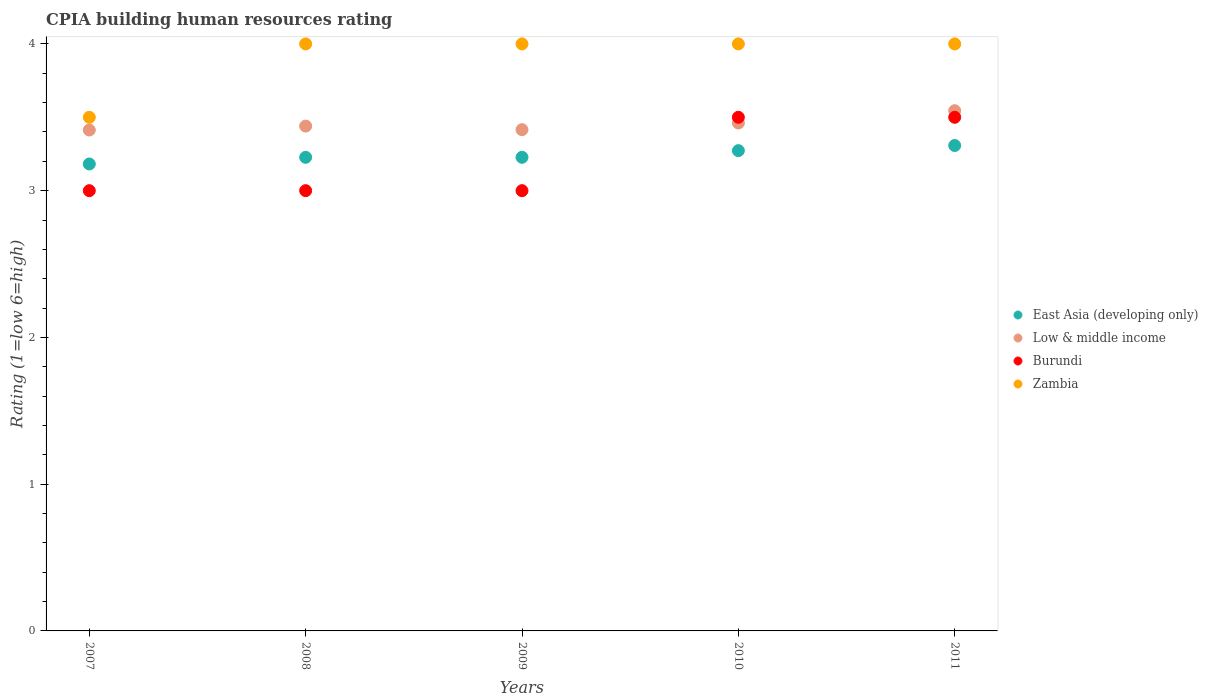Is the number of dotlines equal to the number of legend labels?
Provide a short and direct response. Yes. Across all years, what is the minimum CPIA rating in Zambia?
Keep it short and to the point. 3.5. In which year was the CPIA rating in Low & middle income minimum?
Your response must be concise. 2007. What is the difference between the CPIA rating in Low & middle income in 2009 and that in 2011?
Your answer should be compact. -0.13. What is the difference between the CPIA rating in Zambia in 2009 and the CPIA rating in East Asia (developing only) in 2007?
Make the answer very short. 0.82. What is the average CPIA rating in Low & middle income per year?
Provide a short and direct response. 3.45. In the year 2009, what is the difference between the CPIA rating in Low & middle income and CPIA rating in Zambia?
Your answer should be very brief. -0.58. What is the ratio of the CPIA rating in East Asia (developing only) in 2007 to that in 2009?
Offer a terse response. 0.99. What is the difference between the highest and the lowest CPIA rating in East Asia (developing only)?
Ensure brevity in your answer.  0.13. In how many years, is the CPIA rating in Zambia greater than the average CPIA rating in Zambia taken over all years?
Your response must be concise. 4. Is the sum of the CPIA rating in Burundi in 2007 and 2011 greater than the maximum CPIA rating in Low & middle income across all years?
Offer a very short reply. Yes. Is it the case that in every year, the sum of the CPIA rating in Burundi and CPIA rating in Low & middle income  is greater than the sum of CPIA rating in East Asia (developing only) and CPIA rating in Zambia?
Your response must be concise. No. Is it the case that in every year, the sum of the CPIA rating in East Asia (developing only) and CPIA rating in Burundi  is greater than the CPIA rating in Zambia?
Your answer should be compact. Yes. Is the CPIA rating in East Asia (developing only) strictly greater than the CPIA rating in Zambia over the years?
Your response must be concise. No. Does the graph contain grids?
Give a very brief answer. No. How many legend labels are there?
Offer a very short reply. 4. How are the legend labels stacked?
Provide a short and direct response. Vertical. What is the title of the graph?
Your answer should be very brief. CPIA building human resources rating. Does "Caribbean small states" appear as one of the legend labels in the graph?
Offer a very short reply. No. What is the Rating (1=low 6=high) in East Asia (developing only) in 2007?
Make the answer very short. 3.18. What is the Rating (1=low 6=high) of Low & middle income in 2007?
Your response must be concise. 3.41. What is the Rating (1=low 6=high) in Zambia in 2007?
Ensure brevity in your answer.  3.5. What is the Rating (1=low 6=high) of East Asia (developing only) in 2008?
Provide a short and direct response. 3.23. What is the Rating (1=low 6=high) of Low & middle income in 2008?
Provide a short and direct response. 3.44. What is the Rating (1=low 6=high) of Burundi in 2008?
Provide a short and direct response. 3. What is the Rating (1=low 6=high) in East Asia (developing only) in 2009?
Give a very brief answer. 3.23. What is the Rating (1=low 6=high) in Low & middle income in 2009?
Give a very brief answer. 3.42. What is the Rating (1=low 6=high) in Burundi in 2009?
Keep it short and to the point. 3. What is the Rating (1=low 6=high) in East Asia (developing only) in 2010?
Offer a very short reply. 3.27. What is the Rating (1=low 6=high) in Low & middle income in 2010?
Your answer should be compact. 3.46. What is the Rating (1=low 6=high) of Burundi in 2010?
Offer a terse response. 3.5. What is the Rating (1=low 6=high) in Zambia in 2010?
Offer a terse response. 4. What is the Rating (1=low 6=high) in East Asia (developing only) in 2011?
Make the answer very short. 3.31. What is the Rating (1=low 6=high) in Low & middle income in 2011?
Your answer should be compact. 3.54. Across all years, what is the maximum Rating (1=low 6=high) of East Asia (developing only)?
Ensure brevity in your answer.  3.31. Across all years, what is the maximum Rating (1=low 6=high) in Low & middle income?
Your answer should be compact. 3.54. Across all years, what is the maximum Rating (1=low 6=high) in Zambia?
Keep it short and to the point. 4. Across all years, what is the minimum Rating (1=low 6=high) of East Asia (developing only)?
Your response must be concise. 3.18. Across all years, what is the minimum Rating (1=low 6=high) of Low & middle income?
Offer a very short reply. 3.41. Across all years, what is the minimum Rating (1=low 6=high) of Burundi?
Provide a succinct answer. 3. Across all years, what is the minimum Rating (1=low 6=high) in Zambia?
Offer a very short reply. 3.5. What is the total Rating (1=low 6=high) in East Asia (developing only) in the graph?
Ensure brevity in your answer.  16.22. What is the total Rating (1=low 6=high) of Low & middle income in the graph?
Keep it short and to the point. 17.27. What is the total Rating (1=low 6=high) of Zambia in the graph?
Your answer should be very brief. 19.5. What is the difference between the Rating (1=low 6=high) of East Asia (developing only) in 2007 and that in 2008?
Keep it short and to the point. -0.05. What is the difference between the Rating (1=low 6=high) in Low & middle income in 2007 and that in 2008?
Your answer should be compact. -0.03. What is the difference between the Rating (1=low 6=high) in East Asia (developing only) in 2007 and that in 2009?
Your answer should be compact. -0.05. What is the difference between the Rating (1=low 6=high) of Low & middle income in 2007 and that in 2009?
Your answer should be compact. -0. What is the difference between the Rating (1=low 6=high) in East Asia (developing only) in 2007 and that in 2010?
Keep it short and to the point. -0.09. What is the difference between the Rating (1=low 6=high) in Low & middle income in 2007 and that in 2010?
Your answer should be compact. -0.05. What is the difference between the Rating (1=low 6=high) in Zambia in 2007 and that in 2010?
Your answer should be compact. -0.5. What is the difference between the Rating (1=low 6=high) in East Asia (developing only) in 2007 and that in 2011?
Your answer should be very brief. -0.13. What is the difference between the Rating (1=low 6=high) in Low & middle income in 2007 and that in 2011?
Offer a terse response. -0.13. What is the difference between the Rating (1=low 6=high) of Burundi in 2007 and that in 2011?
Offer a terse response. -0.5. What is the difference between the Rating (1=low 6=high) of East Asia (developing only) in 2008 and that in 2009?
Your answer should be very brief. 0. What is the difference between the Rating (1=low 6=high) in Low & middle income in 2008 and that in 2009?
Provide a succinct answer. 0.02. What is the difference between the Rating (1=low 6=high) in Zambia in 2008 and that in 2009?
Offer a terse response. 0. What is the difference between the Rating (1=low 6=high) of East Asia (developing only) in 2008 and that in 2010?
Provide a short and direct response. -0.05. What is the difference between the Rating (1=low 6=high) of Low & middle income in 2008 and that in 2010?
Make the answer very short. -0.02. What is the difference between the Rating (1=low 6=high) of Burundi in 2008 and that in 2010?
Your answer should be very brief. -0.5. What is the difference between the Rating (1=low 6=high) in Zambia in 2008 and that in 2010?
Your answer should be very brief. 0. What is the difference between the Rating (1=low 6=high) of East Asia (developing only) in 2008 and that in 2011?
Your answer should be very brief. -0.08. What is the difference between the Rating (1=low 6=high) of Low & middle income in 2008 and that in 2011?
Provide a short and direct response. -0.1. What is the difference between the Rating (1=low 6=high) in Burundi in 2008 and that in 2011?
Your response must be concise. -0.5. What is the difference between the Rating (1=low 6=high) of East Asia (developing only) in 2009 and that in 2010?
Your answer should be very brief. -0.05. What is the difference between the Rating (1=low 6=high) of Low & middle income in 2009 and that in 2010?
Provide a succinct answer. -0.05. What is the difference between the Rating (1=low 6=high) of Burundi in 2009 and that in 2010?
Offer a very short reply. -0.5. What is the difference between the Rating (1=low 6=high) of Zambia in 2009 and that in 2010?
Your answer should be very brief. 0. What is the difference between the Rating (1=low 6=high) of East Asia (developing only) in 2009 and that in 2011?
Your answer should be very brief. -0.08. What is the difference between the Rating (1=low 6=high) of Low & middle income in 2009 and that in 2011?
Offer a very short reply. -0.13. What is the difference between the Rating (1=low 6=high) in Burundi in 2009 and that in 2011?
Give a very brief answer. -0.5. What is the difference between the Rating (1=low 6=high) of Zambia in 2009 and that in 2011?
Make the answer very short. 0. What is the difference between the Rating (1=low 6=high) in East Asia (developing only) in 2010 and that in 2011?
Offer a very short reply. -0.04. What is the difference between the Rating (1=low 6=high) of Low & middle income in 2010 and that in 2011?
Provide a short and direct response. -0.08. What is the difference between the Rating (1=low 6=high) in Zambia in 2010 and that in 2011?
Ensure brevity in your answer.  0. What is the difference between the Rating (1=low 6=high) in East Asia (developing only) in 2007 and the Rating (1=low 6=high) in Low & middle income in 2008?
Give a very brief answer. -0.26. What is the difference between the Rating (1=low 6=high) in East Asia (developing only) in 2007 and the Rating (1=low 6=high) in Burundi in 2008?
Make the answer very short. 0.18. What is the difference between the Rating (1=low 6=high) of East Asia (developing only) in 2007 and the Rating (1=low 6=high) of Zambia in 2008?
Keep it short and to the point. -0.82. What is the difference between the Rating (1=low 6=high) in Low & middle income in 2007 and the Rating (1=low 6=high) in Burundi in 2008?
Your answer should be very brief. 0.41. What is the difference between the Rating (1=low 6=high) of Low & middle income in 2007 and the Rating (1=low 6=high) of Zambia in 2008?
Provide a short and direct response. -0.59. What is the difference between the Rating (1=low 6=high) of East Asia (developing only) in 2007 and the Rating (1=low 6=high) of Low & middle income in 2009?
Your response must be concise. -0.23. What is the difference between the Rating (1=low 6=high) in East Asia (developing only) in 2007 and the Rating (1=low 6=high) in Burundi in 2009?
Offer a terse response. 0.18. What is the difference between the Rating (1=low 6=high) in East Asia (developing only) in 2007 and the Rating (1=low 6=high) in Zambia in 2009?
Offer a terse response. -0.82. What is the difference between the Rating (1=low 6=high) in Low & middle income in 2007 and the Rating (1=low 6=high) in Burundi in 2009?
Your response must be concise. 0.41. What is the difference between the Rating (1=low 6=high) in Low & middle income in 2007 and the Rating (1=low 6=high) in Zambia in 2009?
Your answer should be very brief. -0.59. What is the difference between the Rating (1=low 6=high) of Burundi in 2007 and the Rating (1=low 6=high) of Zambia in 2009?
Give a very brief answer. -1. What is the difference between the Rating (1=low 6=high) of East Asia (developing only) in 2007 and the Rating (1=low 6=high) of Low & middle income in 2010?
Keep it short and to the point. -0.28. What is the difference between the Rating (1=low 6=high) of East Asia (developing only) in 2007 and the Rating (1=low 6=high) of Burundi in 2010?
Provide a succinct answer. -0.32. What is the difference between the Rating (1=low 6=high) in East Asia (developing only) in 2007 and the Rating (1=low 6=high) in Zambia in 2010?
Provide a succinct answer. -0.82. What is the difference between the Rating (1=low 6=high) of Low & middle income in 2007 and the Rating (1=low 6=high) of Burundi in 2010?
Keep it short and to the point. -0.09. What is the difference between the Rating (1=low 6=high) of Low & middle income in 2007 and the Rating (1=low 6=high) of Zambia in 2010?
Provide a short and direct response. -0.59. What is the difference between the Rating (1=low 6=high) of East Asia (developing only) in 2007 and the Rating (1=low 6=high) of Low & middle income in 2011?
Provide a short and direct response. -0.36. What is the difference between the Rating (1=low 6=high) in East Asia (developing only) in 2007 and the Rating (1=low 6=high) in Burundi in 2011?
Your response must be concise. -0.32. What is the difference between the Rating (1=low 6=high) in East Asia (developing only) in 2007 and the Rating (1=low 6=high) in Zambia in 2011?
Ensure brevity in your answer.  -0.82. What is the difference between the Rating (1=low 6=high) in Low & middle income in 2007 and the Rating (1=low 6=high) in Burundi in 2011?
Give a very brief answer. -0.09. What is the difference between the Rating (1=low 6=high) of Low & middle income in 2007 and the Rating (1=low 6=high) of Zambia in 2011?
Give a very brief answer. -0.59. What is the difference between the Rating (1=low 6=high) of Burundi in 2007 and the Rating (1=low 6=high) of Zambia in 2011?
Your response must be concise. -1. What is the difference between the Rating (1=low 6=high) of East Asia (developing only) in 2008 and the Rating (1=low 6=high) of Low & middle income in 2009?
Your answer should be very brief. -0.19. What is the difference between the Rating (1=low 6=high) in East Asia (developing only) in 2008 and the Rating (1=low 6=high) in Burundi in 2009?
Provide a short and direct response. 0.23. What is the difference between the Rating (1=low 6=high) of East Asia (developing only) in 2008 and the Rating (1=low 6=high) of Zambia in 2009?
Keep it short and to the point. -0.77. What is the difference between the Rating (1=low 6=high) of Low & middle income in 2008 and the Rating (1=low 6=high) of Burundi in 2009?
Your response must be concise. 0.44. What is the difference between the Rating (1=low 6=high) of Low & middle income in 2008 and the Rating (1=low 6=high) of Zambia in 2009?
Your answer should be very brief. -0.56. What is the difference between the Rating (1=low 6=high) of East Asia (developing only) in 2008 and the Rating (1=low 6=high) of Low & middle income in 2010?
Give a very brief answer. -0.23. What is the difference between the Rating (1=low 6=high) in East Asia (developing only) in 2008 and the Rating (1=low 6=high) in Burundi in 2010?
Keep it short and to the point. -0.27. What is the difference between the Rating (1=low 6=high) of East Asia (developing only) in 2008 and the Rating (1=low 6=high) of Zambia in 2010?
Your answer should be very brief. -0.77. What is the difference between the Rating (1=low 6=high) of Low & middle income in 2008 and the Rating (1=low 6=high) of Burundi in 2010?
Provide a succinct answer. -0.06. What is the difference between the Rating (1=low 6=high) in Low & middle income in 2008 and the Rating (1=low 6=high) in Zambia in 2010?
Ensure brevity in your answer.  -0.56. What is the difference between the Rating (1=low 6=high) in East Asia (developing only) in 2008 and the Rating (1=low 6=high) in Low & middle income in 2011?
Keep it short and to the point. -0.32. What is the difference between the Rating (1=low 6=high) in East Asia (developing only) in 2008 and the Rating (1=low 6=high) in Burundi in 2011?
Give a very brief answer. -0.27. What is the difference between the Rating (1=low 6=high) of East Asia (developing only) in 2008 and the Rating (1=low 6=high) of Zambia in 2011?
Make the answer very short. -0.77. What is the difference between the Rating (1=low 6=high) in Low & middle income in 2008 and the Rating (1=low 6=high) in Burundi in 2011?
Ensure brevity in your answer.  -0.06. What is the difference between the Rating (1=low 6=high) in Low & middle income in 2008 and the Rating (1=low 6=high) in Zambia in 2011?
Provide a short and direct response. -0.56. What is the difference between the Rating (1=low 6=high) in Burundi in 2008 and the Rating (1=low 6=high) in Zambia in 2011?
Give a very brief answer. -1. What is the difference between the Rating (1=low 6=high) in East Asia (developing only) in 2009 and the Rating (1=low 6=high) in Low & middle income in 2010?
Your answer should be compact. -0.23. What is the difference between the Rating (1=low 6=high) in East Asia (developing only) in 2009 and the Rating (1=low 6=high) in Burundi in 2010?
Your answer should be very brief. -0.27. What is the difference between the Rating (1=low 6=high) of East Asia (developing only) in 2009 and the Rating (1=low 6=high) of Zambia in 2010?
Ensure brevity in your answer.  -0.77. What is the difference between the Rating (1=low 6=high) in Low & middle income in 2009 and the Rating (1=low 6=high) in Burundi in 2010?
Keep it short and to the point. -0.08. What is the difference between the Rating (1=low 6=high) of Low & middle income in 2009 and the Rating (1=low 6=high) of Zambia in 2010?
Provide a short and direct response. -0.58. What is the difference between the Rating (1=low 6=high) of Burundi in 2009 and the Rating (1=low 6=high) of Zambia in 2010?
Provide a short and direct response. -1. What is the difference between the Rating (1=low 6=high) in East Asia (developing only) in 2009 and the Rating (1=low 6=high) in Low & middle income in 2011?
Provide a succinct answer. -0.32. What is the difference between the Rating (1=low 6=high) in East Asia (developing only) in 2009 and the Rating (1=low 6=high) in Burundi in 2011?
Offer a very short reply. -0.27. What is the difference between the Rating (1=low 6=high) of East Asia (developing only) in 2009 and the Rating (1=low 6=high) of Zambia in 2011?
Your response must be concise. -0.77. What is the difference between the Rating (1=low 6=high) of Low & middle income in 2009 and the Rating (1=low 6=high) of Burundi in 2011?
Keep it short and to the point. -0.08. What is the difference between the Rating (1=low 6=high) in Low & middle income in 2009 and the Rating (1=low 6=high) in Zambia in 2011?
Ensure brevity in your answer.  -0.58. What is the difference between the Rating (1=low 6=high) in Burundi in 2009 and the Rating (1=low 6=high) in Zambia in 2011?
Give a very brief answer. -1. What is the difference between the Rating (1=low 6=high) in East Asia (developing only) in 2010 and the Rating (1=low 6=high) in Low & middle income in 2011?
Keep it short and to the point. -0.27. What is the difference between the Rating (1=low 6=high) of East Asia (developing only) in 2010 and the Rating (1=low 6=high) of Burundi in 2011?
Your response must be concise. -0.23. What is the difference between the Rating (1=low 6=high) of East Asia (developing only) in 2010 and the Rating (1=low 6=high) of Zambia in 2011?
Provide a succinct answer. -0.73. What is the difference between the Rating (1=low 6=high) in Low & middle income in 2010 and the Rating (1=low 6=high) in Burundi in 2011?
Provide a succinct answer. -0.04. What is the difference between the Rating (1=low 6=high) in Low & middle income in 2010 and the Rating (1=low 6=high) in Zambia in 2011?
Your answer should be very brief. -0.54. What is the average Rating (1=low 6=high) in East Asia (developing only) per year?
Offer a terse response. 3.24. What is the average Rating (1=low 6=high) of Low & middle income per year?
Keep it short and to the point. 3.46. What is the average Rating (1=low 6=high) of Burundi per year?
Make the answer very short. 3.2. In the year 2007, what is the difference between the Rating (1=low 6=high) in East Asia (developing only) and Rating (1=low 6=high) in Low & middle income?
Offer a very short reply. -0.23. In the year 2007, what is the difference between the Rating (1=low 6=high) of East Asia (developing only) and Rating (1=low 6=high) of Burundi?
Provide a short and direct response. 0.18. In the year 2007, what is the difference between the Rating (1=low 6=high) in East Asia (developing only) and Rating (1=low 6=high) in Zambia?
Give a very brief answer. -0.32. In the year 2007, what is the difference between the Rating (1=low 6=high) in Low & middle income and Rating (1=low 6=high) in Burundi?
Provide a short and direct response. 0.41. In the year 2007, what is the difference between the Rating (1=low 6=high) in Low & middle income and Rating (1=low 6=high) in Zambia?
Your answer should be compact. -0.09. In the year 2007, what is the difference between the Rating (1=low 6=high) in Burundi and Rating (1=low 6=high) in Zambia?
Provide a succinct answer. -0.5. In the year 2008, what is the difference between the Rating (1=low 6=high) in East Asia (developing only) and Rating (1=low 6=high) in Low & middle income?
Ensure brevity in your answer.  -0.21. In the year 2008, what is the difference between the Rating (1=low 6=high) of East Asia (developing only) and Rating (1=low 6=high) of Burundi?
Your response must be concise. 0.23. In the year 2008, what is the difference between the Rating (1=low 6=high) in East Asia (developing only) and Rating (1=low 6=high) in Zambia?
Your answer should be very brief. -0.77. In the year 2008, what is the difference between the Rating (1=low 6=high) of Low & middle income and Rating (1=low 6=high) of Burundi?
Give a very brief answer. 0.44. In the year 2008, what is the difference between the Rating (1=low 6=high) of Low & middle income and Rating (1=low 6=high) of Zambia?
Provide a succinct answer. -0.56. In the year 2009, what is the difference between the Rating (1=low 6=high) in East Asia (developing only) and Rating (1=low 6=high) in Low & middle income?
Your answer should be very brief. -0.19. In the year 2009, what is the difference between the Rating (1=low 6=high) in East Asia (developing only) and Rating (1=low 6=high) in Burundi?
Provide a succinct answer. 0.23. In the year 2009, what is the difference between the Rating (1=low 6=high) in East Asia (developing only) and Rating (1=low 6=high) in Zambia?
Keep it short and to the point. -0.77. In the year 2009, what is the difference between the Rating (1=low 6=high) of Low & middle income and Rating (1=low 6=high) of Burundi?
Make the answer very short. 0.42. In the year 2009, what is the difference between the Rating (1=low 6=high) in Low & middle income and Rating (1=low 6=high) in Zambia?
Your answer should be very brief. -0.58. In the year 2010, what is the difference between the Rating (1=low 6=high) in East Asia (developing only) and Rating (1=low 6=high) in Low & middle income?
Keep it short and to the point. -0.19. In the year 2010, what is the difference between the Rating (1=low 6=high) in East Asia (developing only) and Rating (1=low 6=high) in Burundi?
Your answer should be very brief. -0.23. In the year 2010, what is the difference between the Rating (1=low 6=high) in East Asia (developing only) and Rating (1=low 6=high) in Zambia?
Your answer should be compact. -0.73. In the year 2010, what is the difference between the Rating (1=low 6=high) in Low & middle income and Rating (1=low 6=high) in Burundi?
Make the answer very short. -0.04. In the year 2010, what is the difference between the Rating (1=low 6=high) in Low & middle income and Rating (1=low 6=high) in Zambia?
Your answer should be compact. -0.54. In the year 2011, what is the difference between the Rating (1=low 6=high) in East Asia (developing only) and Rating (1=low 6=high) in Low & middle income?
Your answer should be very brief. -0.24. In the year 2011, what is the difference between the Rating (1=low 6=high) of East Asia (developing only) and Rating (1=low 6=high) of Burundi?
Keep it short and to the point. -0.19. In the year 2011, what is the difference between the Rating (1=low 6=high) of East Asia (developing only) and Rating (1=low 6=high) of Zambia?
Keep it short and to the point. -0.69. In the year 2011, what is the difference between the Rating (1=low 6=high) in Low & middle income and Rating (1=low 6=high) in Burundi?
Ensure brevity in your answer.  0.04. In the year 2011, what is the difference between the Rating (1=low 6=high) of Low & middle income and Rating (1=low 6=high) of Zambia?
Offer a very short reply. -0.46. In the year 2011, what is the difference between the Rating (1=low 6=high) of Burundi and Rating (1=low 6=high) of Zambia?
Provide a short and direct response. -0.5. What is the ratio of the Rating (1=low 6=high) of East Asia (developing only) in 2007 to that in 2008?
Give a very brief answer. 0.99. What is the ratio of the Rating (1=low 6=high) of Burundi in 2007 to that in 2008?
Give a very brief answer. 1. What is the ratio of the Rating (1=low 6=high) of East Asia (developing only) in 2007 to that in 2009?
Make the answer very short. 0.99. What is the ratio of the Rating (1=low 6=high) of Low & middle income in 2007 to that in 2009?
Your response must be concise. 1. What is the ratio of the Rating (1=low 6=high) of East Asia (developing only) in 2007 to that in 2010?
Ensure brevity in your answer.  0.97. What is the ratio of the Rating (1=low 6=high) in Low & middle income in 2007 to that in 2010?
Make the answer very short. 0.99. What is the ratio of the Rating (1=low 6=high) in Burundi in 2007 to that in 2010?
Provide a succinct answer. 0.86. What is the ratio of the Rating (1=low 6=high) of East Asia (developing only) in 2007 to that in 2011?
Provide a short and direct response. 0.96. What is the ratio of the Rating (1=low 6=high) in Low & middle income in 2007 to that in 2011?
Provide a short and direct response. 0.96. What is the ratio of the Rating (1=low 6=high) in East Asia (developing only) in 2008 to that in 2009?
Offer a terse response. 1. What is the ratio of the Rating (1=low 6=high) of Low & middle income in 2008 to that in 2009?
Your answer should be compact. 1.01. What is the ratio of the Rating (1=low 6=high) of Burundi in 2008 to that in 2009?
Make the answer very short. 1. What is the ratio of the Rating (1=low 6=high) in Zambia in 2008 to that in 2009?
Offer a terse response. 1. What is the ratio of the Rating (1=low 6=high) in East Asia (developing only) in 2008 to that in 2010?
Give a very brief answer. 0.99. What is the ratio of the Rating (1=low 6=high) in Burundi in 2008 to that in 2010?
Your answer should be compact. 0.86. What is the ratio of the Rating (1=low 6=high) in Zambia in 2008 to that in 2010?
Offer a very short reply. 1. What is the ratio of the Rating (1=low 6=high) of East Asia (developing only) in 2008 to that in 2011?
Your answer should be compact. 0.98. What is the ratio of the Rating (1=low 6=high) in Low & middle income in 2008 to that in 2011?
Make the answer very short. 0.97. What is the ratio of the Rating (1=low 6=high) in Burundi in 2008 to that in 2011?
Give a very brief answer. 0.86. What is the ratio of the Rating (1=low 6=high) in East Asia (developing only) in 2009 to that in 2010?
Offer a terse response. 0.99. What is the ratio of the Rating (1=low 6=high) in Low & middle income in 2009 to that in 2010?
Ensure brevity in your answer.  0.99. What is the ratio of the Rating (1=low 6=high) of East Asia (developing only) in 2009 to that in 2011?
Give a very brief answer. 0.98. What is the ratio of the Rating (1=low 6=high) of Low & middle income in 2009 to that in 2011?
Your answer should be very brief. 0.96. What is the ratio of the Rating (1=low 6=high) in Burundi in 2009 to that in 2011?
Provide a short and direct response. 0.86. What is the ratio of the Rating (1=low 6=high) in Low & middle income in 2010 to that in 2011?
Offer a terse response. 0.98. What is the difference between the highest and the second highest Rating (1=low 6=high) of East Asia (developing only)?
Keep it short and to the point. 0.04. What is the difference between the highest and the second highest Rating (1=low 6=high) in Low & middle income?
Provide a succinct answer. 0.08. What is the difference between the highest and the second highest Rating (1=low 6=high) of Zambia?
Offer a very short reply. 0. What is the difference between the highest and the lowest Rating (1=low 6=high) of East Asia (developing only)?
Offer a terse response. 0.13. What is the difference between the highest and the lowest Rating (1=low 6=high) of Low & middle income?
Give a very brief answer. 0.13. What is the difference between the highest and the lowest Rating (1=low 6=high) in Zambia?
Your response must be concise. 0.5. 